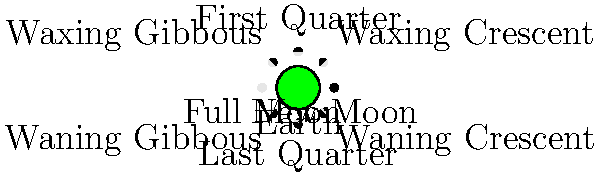Based on the diagram showing the phases of the Moon as seen from Earth, what causes the different appearances of the Moon throughout its cycle, and why do we always see the same side of the Moon from Earth? To understand the Moon's phases and why we always see the same side, let's break it down step-by-step:

1. Moon's orbit: The Moon orbits around the Earth approximately every 27.3 days (sidereal month).

2. Illumination: The Sun always illuminates half of the Moon's surface.

3. Viewing angle: The phase we see depends on the relative positions of the Earth, Moon, and Sun.

4. New Moon: When the Moon is between the Earth and Sun, we see the unlit side (dark).

5. Waxing phases: As the Moon moves eastward in its orbit, we see more of the lit side (Crescent → First Quarter → Gibbous).

6. Full Moon: When the Earth is between the Moon and Sun, we see the fully lit side.

7. Waning phases: As the Moon continues its orbit, we see less of the lit side (Gibbous → Last Quarter → Crescent).

8. Synchronous rotation: The Moon rotates on its axis at the same rate it orbits the Earth, a phenomenon called tidal locking.

9. Tidal locking explanation:
   a. Earth's gravity creates tidal bulges on the Moon.
   b. These bulges created friction and slowed the Moon's rotation.
   c. Over millions of years, the rotation synchronized with the orbital period.

10. Result of tidal locking: The same side of the Moon always faces Earth, while the far side remains hidden from direct view.

This synchronous rotation, combined with the changing angles of solar illumination as the Moon orbits Earth, creates the cycle of phases we observe.
Answer: The Moon's phases are caused by changing angles of solar illumination as it orbits Earth. We always see the same side due to tidal locking. 